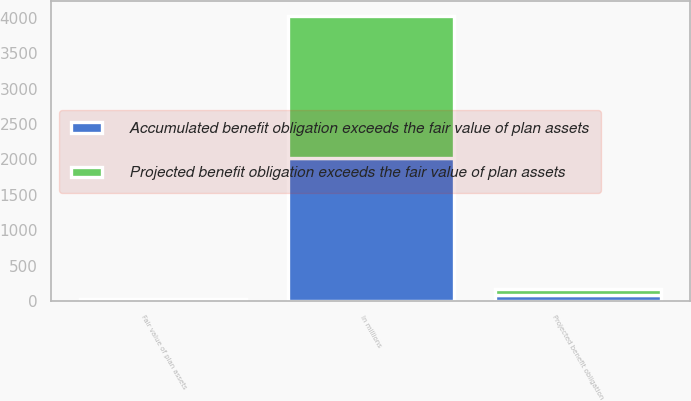Convert chart to OTSL. <chart><loc_0><loc_0><loc_500><loc_500><stacked_bar_chart><ecel><fcel>In millions<fcel>Projected benefit obligation<fcel>Fair value of plan assets<nl><fcel>Accumulated benefit obligation exceeds the fair value of plan assets<fcel>2015<fcel>86.4<fcel>16.6<nl><fcel>Projected benefit obligation exceeds the fair value of plan assets<fcel>2015<fcel>86.4<fcel>16.6<nl></chart> 